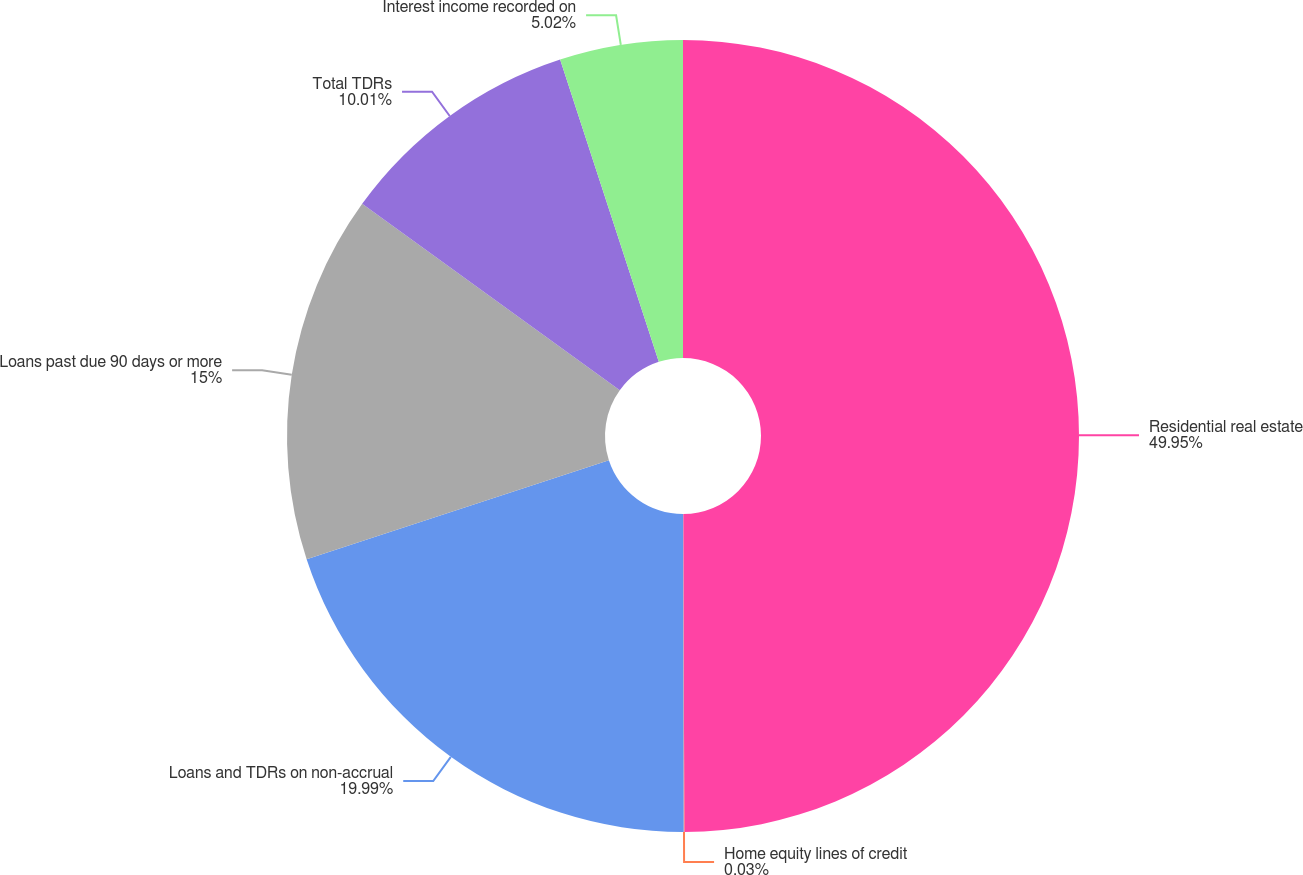<chart> <loc_0><loc_0><loc_500><loc_500><pie_chart><fcel>Residential real estate<fcel>Home equity lines of credit<fcel>Loans and TDRs on non-accrual<fcel>Loans past due 90 days or more<fcel>Total TDRs<fcel>Interest income recorded on<nl><fcel>49.94%<fcel>0.03%<fcel>19.99%<fcel>15.0%<fcel>10.01%<fcel>5.02%<nl></chart> 